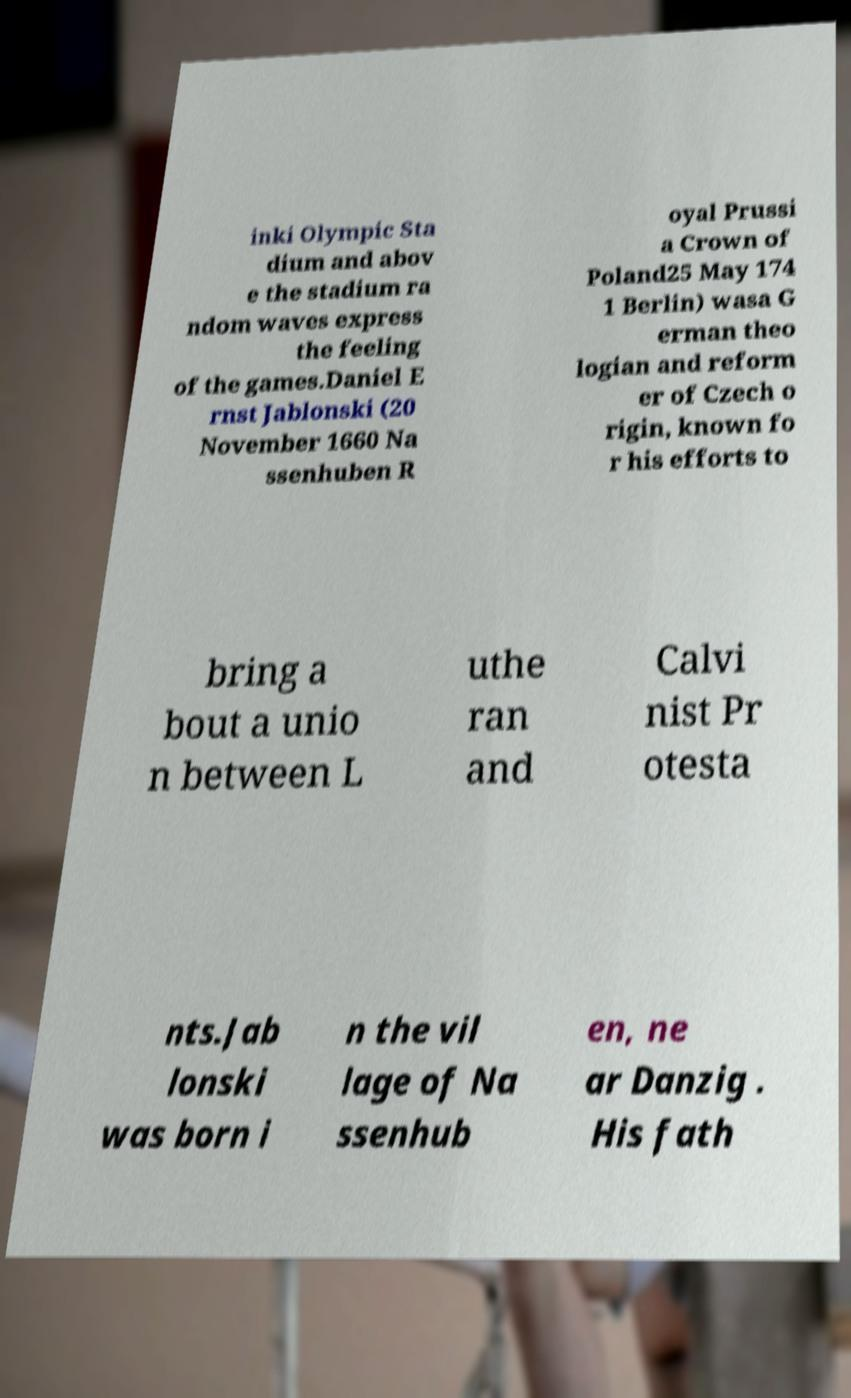For documentation purposes, I need the text within this image transcribed. Could you provide that? inki Olympic Sta dium and abov e the stadium ra ndom waves express the feeling of the games.Daniel E rnst Jablonski (20 November 1660 Na ssenhuben R oyal Prussi a Crown of Poland25 May 174 1 Berlin) wasa G erman theo logian and reform er of Czech o rigin, known fo r his efforts to bring a bout a unio n between L uthe ran and Calvi nist Pr otesta nts.Jab lonski was born i n the vil lage of Na ssenhub en, ne ar Danzig . His fath 